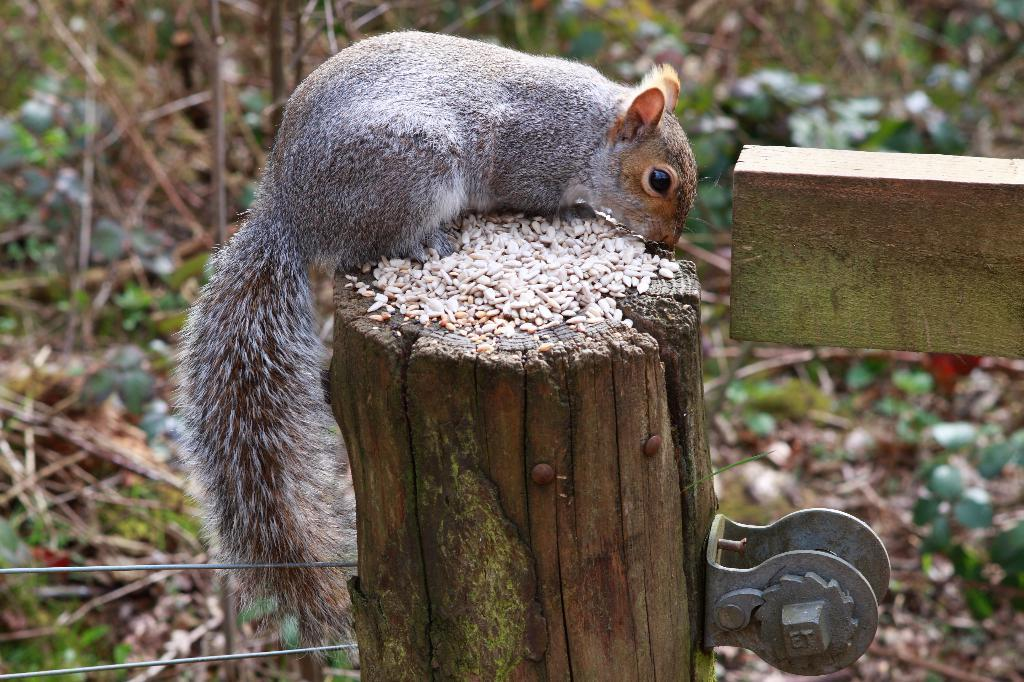What type of animal can be seen in the image? There is a squirrel in the image. What material is visible in the front of the image? There is wood in the front of the image. What can be seen in the background of the image? There are leaves and plants in the background of the image. What type of smile can be seen on the canvas in the image? There is no canvas present in the image, and therefore no smile can be seen on it. 